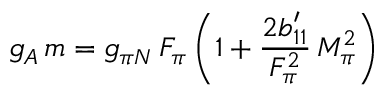<formula> <loc_0><loc_0><loc_500><loc_500>g _ { A } \, m = g _ { \pi N } \, F _ { \pi } \, \left ( 1 + \frac { 2 b _ { 1 1 } ^ { \prime } } { F _ { \pi } ^ { 2 } } \, M _ { \pi } ^ { 2 } \right )</formula> 